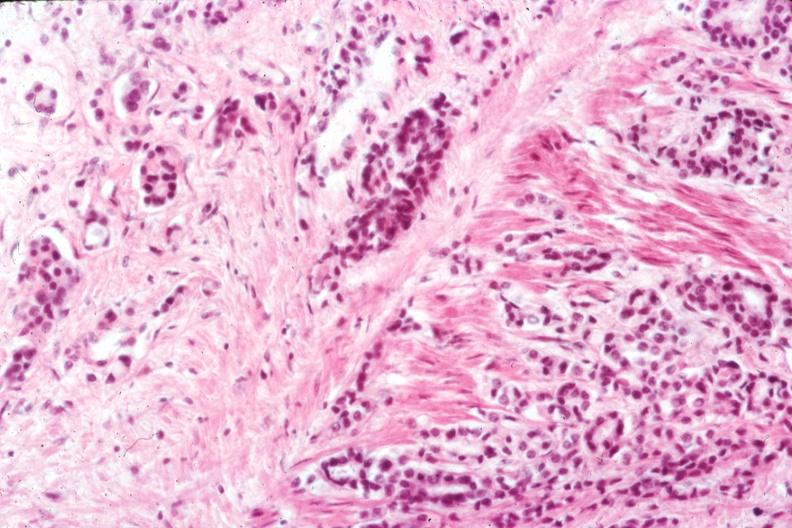s prostate present?
Answer the question using a single word or phrase. Yes 